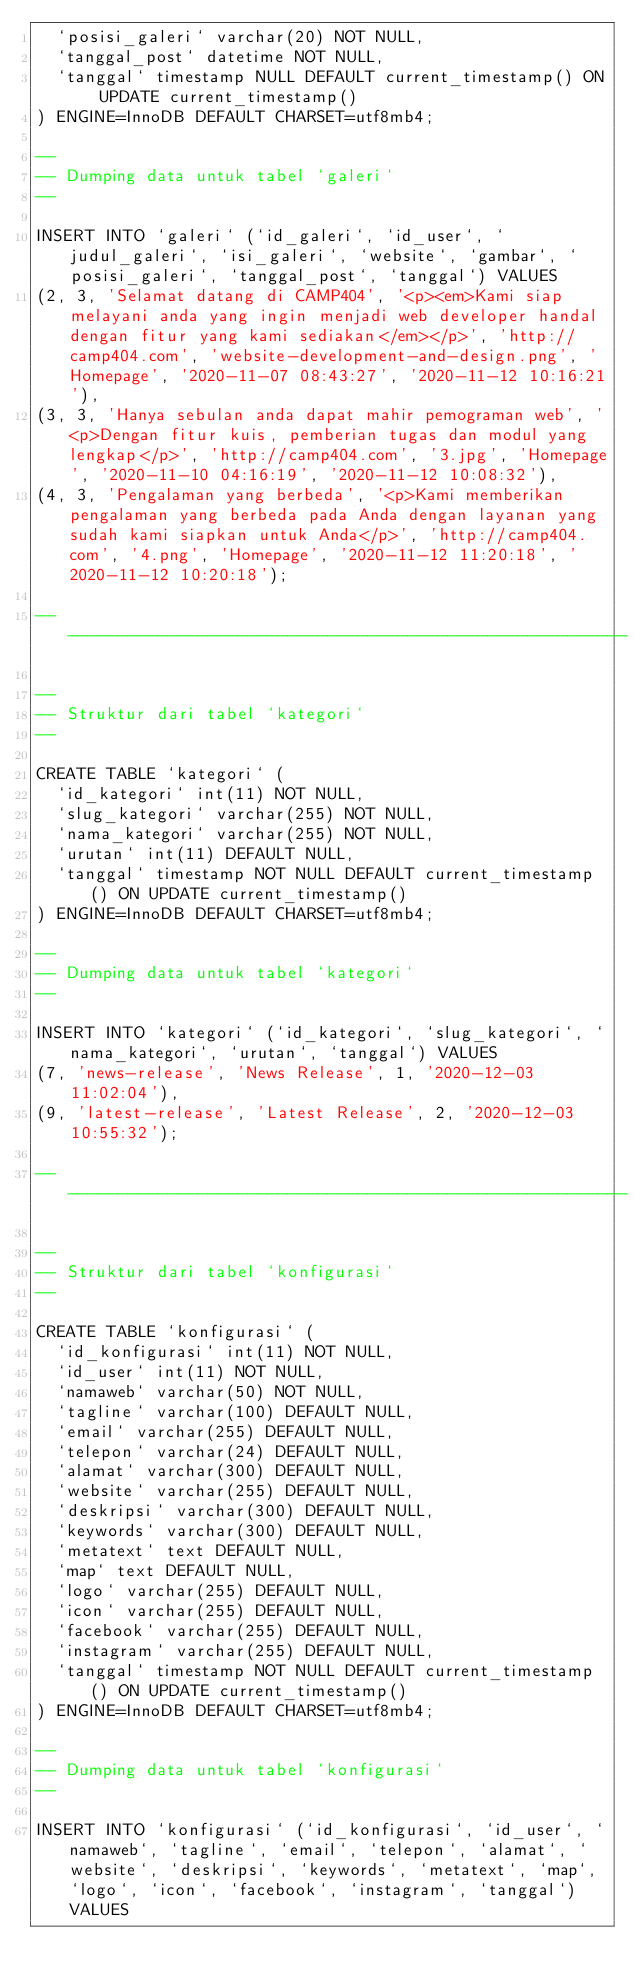<code> <loc_0><loc_0><loc_500><loc_500><_SQL_>  `posisi_galeri` varchar(20) NOT NULL,
  `tanggal_post` datetime NOT NULL,
  `tanggal` timestamp NULL DEFAULT current_timestamp() ON UPDATE current_timestamp()
) ENGINE=InnoDB DEFAULT CHARSET=utf8mb4;

--
-- Dumping data untuk tabel `galeri`
--

INSERT INTO `galeri` (`id_galeri`, `id_user`, `judul_galeri`, `isi_galeri`, `website`, `gambar`, `posisi_galeri`, `tanggal_post`, `tanggal`) VALUES
(2, 3, 'Selamat datang di CAMP404', '<p><em>Kami siap melayani anda yang ingin menjadi web developer handal dengan fitur yang kami sediakan</em></p>', 'http://camp404.com', 'website-development-and-design.png', 'Homepage', '2020-11-07 08:43:27', '2020-11-12 10:16:21'),
(3, 3, 'Hanya sebulan anda dapat mahir pemograman web', '<p>Dengan fitur kuis, pemberian tugas dan modul yang lengkap</p>', 'http://camp404.com', '3.jpg', 'Homepage', '2020-11-10 04:16:19', '2020-11-12 10:08:32'),
(4, 3, 'Pengalaman yang berbeda', '<p>Kami memberikan pengalaman yang berbeda pada Anda dengan layanan yang sudah kami siapkan untuk Anda</p>', 'http://camp404.com', '4.png', 'Homepage', '2020-11-12 11:20:18', '2020-11-12 10:20:18');

-- --------------------------------------------------------

--
-- Struktur dari tabel `kategori`
--

CREATE TABLE `kategori` (
  `id_kategori` int(11) NOT NULL,
  `slug_kategori` varchar(255) NOT NULL,
  `nama_kategori` varchar(255) NOT NULL,
  `urutan` int(11) DEFAULT NULL,
  `tanggal` timestamp NOT NULL DEFAULT current_timestamp() ON UPDATE current_timestamp()
) ENGINE=InnoDB DEFAULT CHARSET=utf8mb4;

--
-- Dumping data untuk tabel `kategori`
--

INSERT INTO `kategori` (`id_kategori`, `slug_kategori`, `nama_kategori`, `urutan`, `tanggal`) VALUES
(7, 'news-release', 'News Release', 1, '2020-12-03 11:02:04'),
(9, 'latest-release', 'Latest Release', 2, '2020-12-03 10:55:32');

-- --------------------------------------------------------

--
-- Struktur dari tabel `konfigurasi`
--

CREATE TABLE `konfigurasi` (
  `id_konfigurasi` int(11) NOT NULL,
  `id_user` int(11) NOT NULL,
  `namaweb` varchar(50) NOT NULL,
  `tagline` varchar(100) DEFAULT NULL,
  `email` varchar(255) DEFAULT NULL,
  `telepon` varchar(24) DEFAULT NULL,
  `alamat` varchar(300) DEFAULT NULL,
  `website` varchar(255) DEFAULT NULL,
  `deskripsi` varchar(300) DEFAULT NULL,
  `keywords` varchar(300) DEFAULT NULL,
  `metatext` text DEFAULT NULL,
  `map` text DEFAULT NULL,
  `logo` varchar(255) DEFAULT NULL,
  `icon` varchar(255) DEFAULT NULL,
  `facebook` varchar(255) DEFAULT NULL,
  `instagram` varchar(255) DEFAULT NULL,
  `tanggal` timestamp NOT NULL DEFAULT current_timestamp() ON UPDATE current_timestamp()
) ENGINE=InnoDB DEFAULT CHARSET=utf8mb4;

--
-- Dumping data untuk tabel `konfigurasi`
--

INSERT INTO `konfigurasi` (`id_konfigurasi`, `id_user`, `namaweb`, `tagline`, `email`, `telepon`, `alamat`, `website`, `deskripsi`, `keywords`, `metatext`, `map`, `logo`, `icon`, `facebook`, `instagram`, `tanggal`) VALUES</code> 